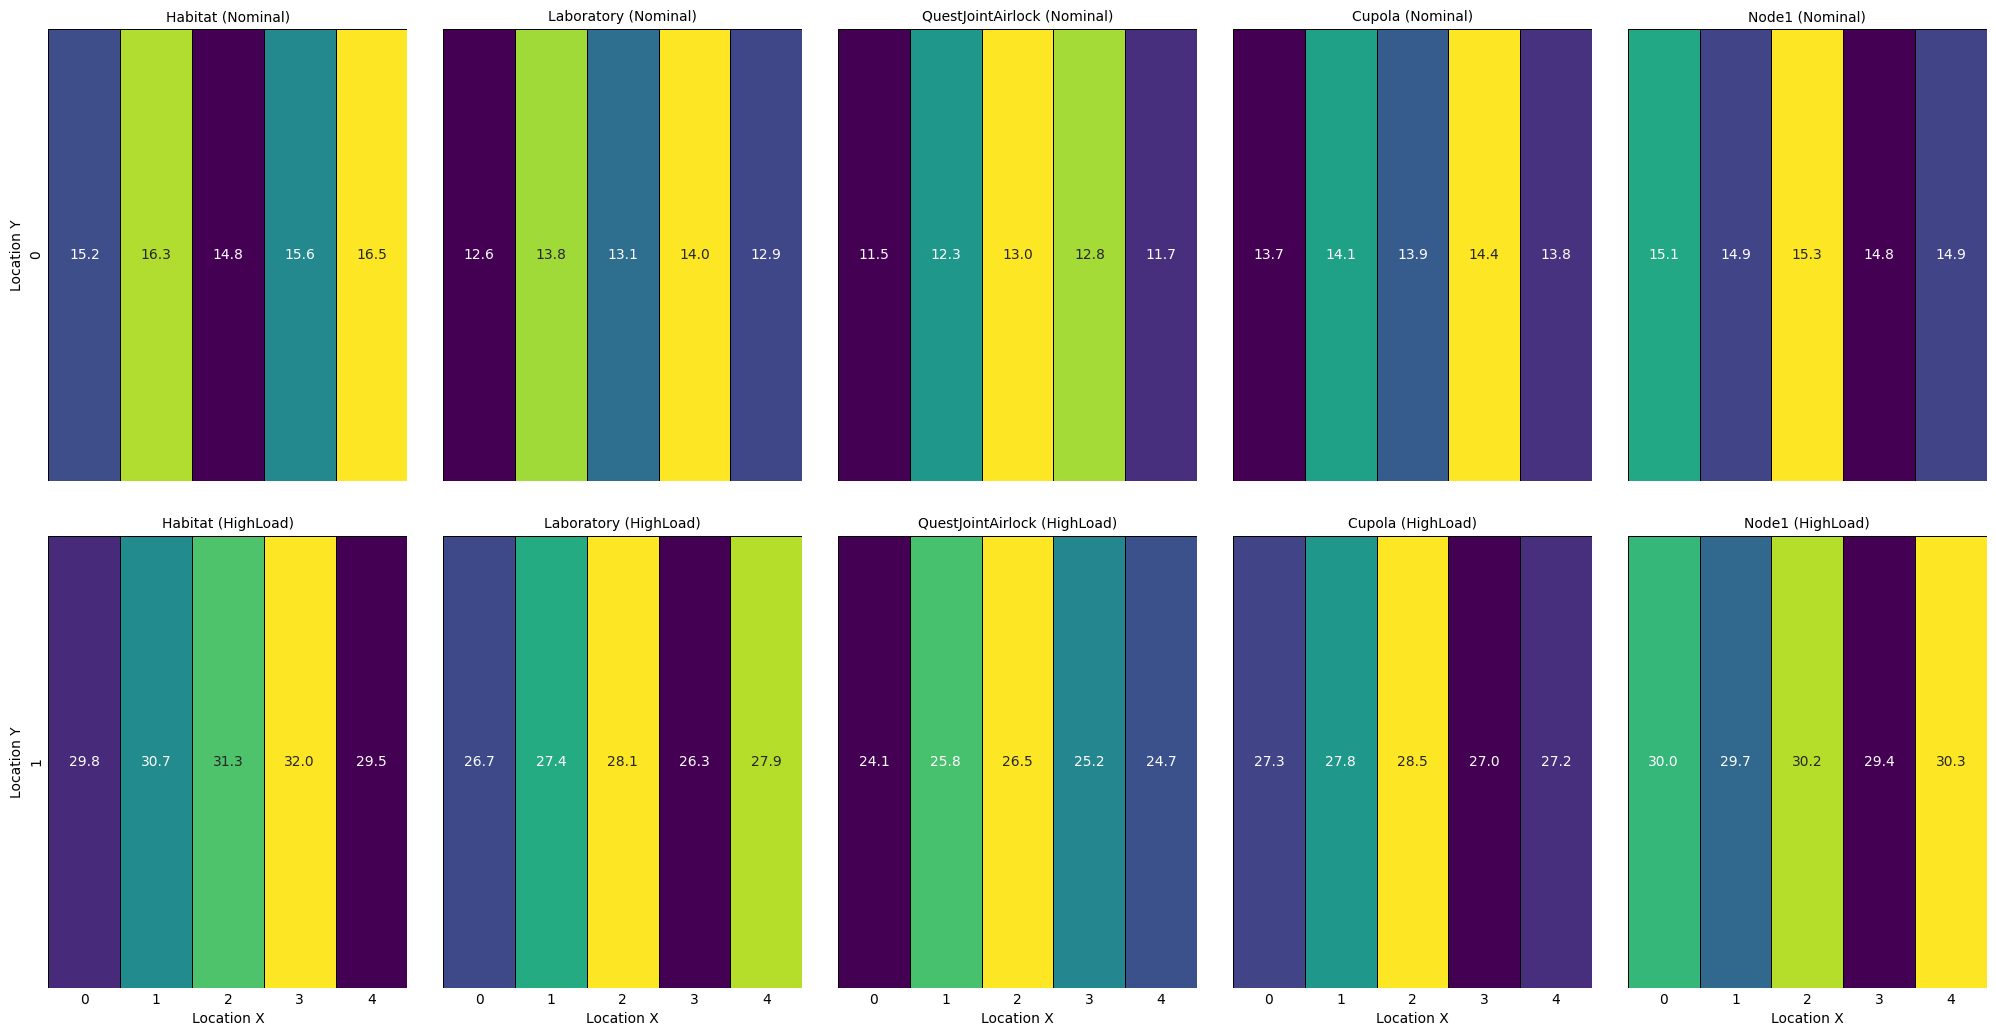Which module experiences the highest stress under nominal load conditions? Look for the highest value among all the modules under nominal load conditions in the heatmap.
Answer: Habitat Which load condition results in higher stress values for the Laboratory module, nominal or high load? Compare the stress values for the Laboratory module under both nominal and high load conditions and see which is higher overall.
Answer: High load What is the average stress in the QuestJointAirlock module under both load conditions combined? Calculate the average of all stress values in the QuestJointAirlock module for both nominal and high load conditions. Detailed steps:
1. Sum all stress values for QuestJointAirlock:
   - Nominal: (11.5 + 12.3 + 13.0 + 12.8 + 11.7) = 61.3
   - HighLoad: (24.1 + 25.8 + 26.5 + 25.2 + 24.7) = 126.3
   - Combined: 61.3 + 126.3 = 187.6
2. Divide the total by the number of data points, which is 10.
   - Average: 187.6 / 10 = 18.76
Answer: 18.76 Compare the stress values between Cupola at LocationX = 3 under nominal and high load conditions. Find the stress values for the Cupola module at LocationX = 3 for both nominal and high load conditions and compare them.
Answer: Nominal: 14.4, High load: 27.0 What is the most visually prominent color trend observed in the heatmap for various modules under high load conditions? Observe the dominant colors in the heatmap for modules under high load to identify the trend.
Answer: Green and yellow shades predominant Between Node1 and Cupola, which module shows lower average stress under high load conditions? Calculate and compare the average stress for Node1 and Cupola under high load conditions:
1. Node1 (HighLoad): (30.0 + 29.7 + 30.2 + 29.4 + 30.3) = 149.6, average = 149.6 / 5 = 29.92
2. Cupola (HighLoad): (27.3 + 27.8 + 28.5 + 27.0 + 27.2) = 137.8, average = 137.8 / 5 = 27.56
Answer: Cupola What is the difference in stress at LocationY = 0 between nominal and high load conditions in the Habitat module? Calculate the stress difference for the Habitat module at LocationY = 0 under both conditions: HighLoad (29.8) - Nominal (15.2) = 14.6
Answer: 14.6 